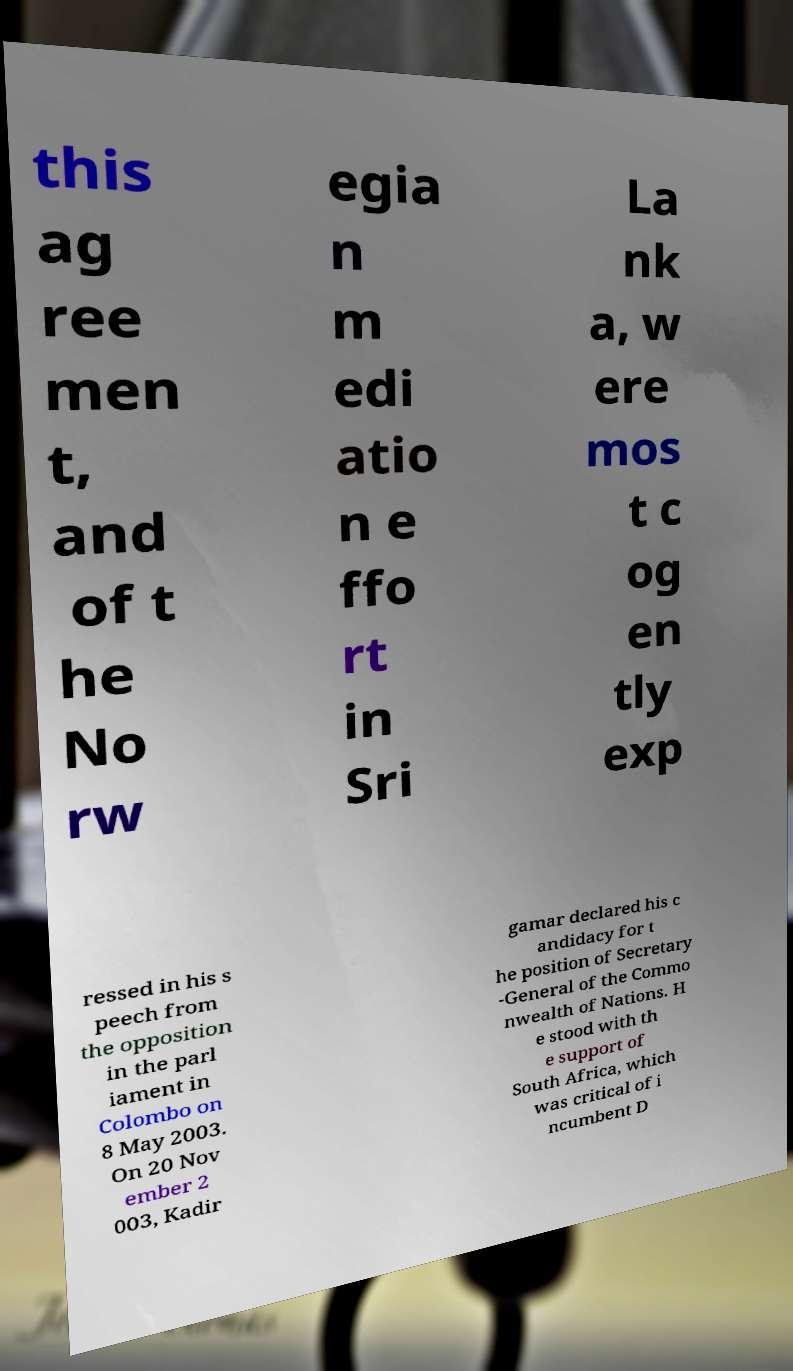I need the written content from this picture converted into text. Can you do that? this ag ree men t, and of t he No rw egia n m edi atio n e ffo rt in Sri La nk a, w ere mos t c og en tly exp ressed in his s peech from the opposition in the parl iament in Colombo on 8 May 2003. On 20 Nov ember 2 003, Kadir gamar declared his c andidacy for t he position of Secretary -General of the Commo nwealth of Nations. H e stood with th e support of South Africa, which was critical of i ncumbent D 